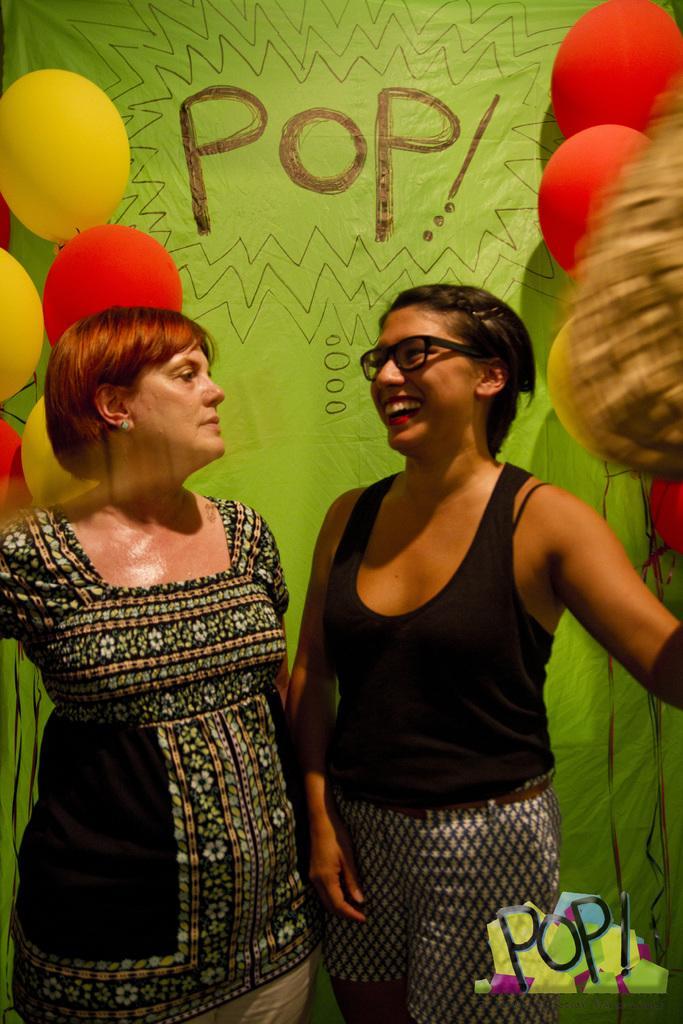How would you summarize this image in a sentence or two? In this image I can see two women are standing. Here I can see she is wearing black dress, specs and I can also see smile on her face. In the background I can see number of balloons, a green colour thing and on it I can see something is written. 